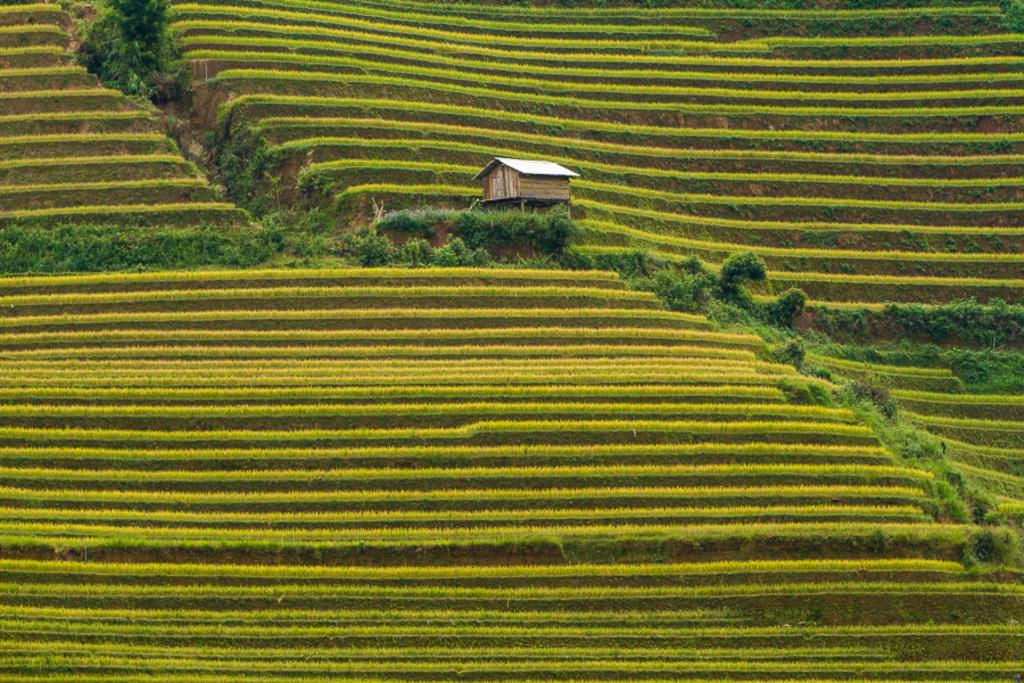What type of farming is shown in the image? The image depicts step farming. What type of vegetation can be seen in the image? There are small bushes in the image. What type of structure is present in the image? There is a small wooden house in the image. What type of advertisement can be seen on the small wooden house in the image? There is no advertisement present on the small wooden house in the image. How many ladybugs can be seen on the small bushes in the image? There are no ladybugs present in the image. 